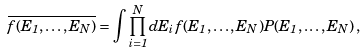<formula> <loc_0><loc_0><loc_500><loc_500>\overline { f ( E _ { 1 } , \dots , E _ { N } ) } = \int \prod _ { i = 1 } ^ { N } d E _ { i } \, f ( E _ { 1 } , \dots , E _ { N } ) P ( E _ { 1 } , \dots , E _ { N } ) \, ,</formula> 